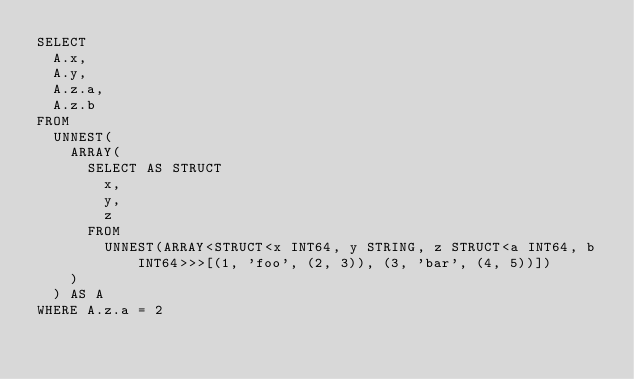<code> <loc_0><loc_0><loc_500><loc_500><_SQL_>SELECT
  A.x,
  A.y,
  A.z.a,
  A.z.b
FROM
  UNNEST(
    ARRAY(
      SELECT AS STRUCT
        x,
        y,
        z
      FROM
        UNNEST(ARRAY<STRUCT<x INT64, y STRING, z STRUCT<a INT64, b INT64>>>[(1, 'foo', (2, 3)), (3, 'bar', (4, 5))])
    )
  ) AS A
WHERE A.z.a = 2
</code> 